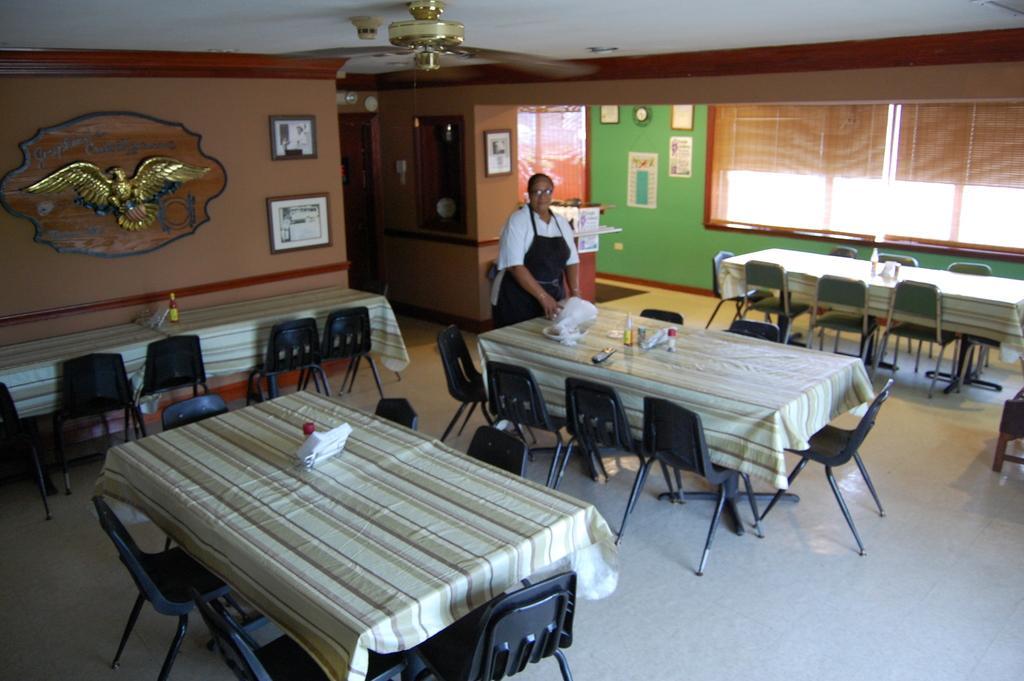How would you summarize this image in a sentence or two? in this picture we can see a woman wore apron, spectacle standing beside the table and on table we have bottle, cover, tissue papers, cloth and in the background we can see wall with eagle, frames, watch and window with curtains. 